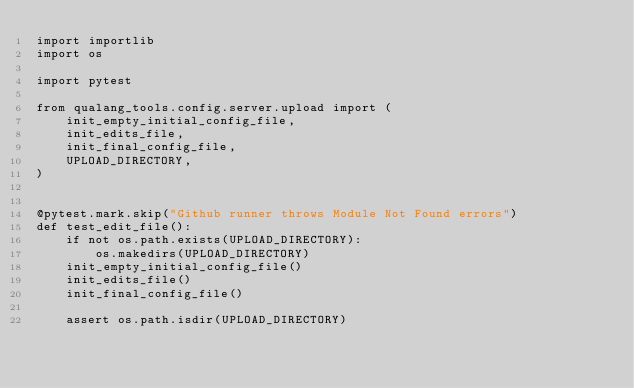Convert code to text. <code><loc_0><loc_0><loc_500><loc_500><_Python_>import importlib
import os

import pytest

from qualang_tools.config.server.upload import (
    init_empty_initial_config_file,
    init_edits_file,
    init_final_config_file,
    UPLOAD_DIRECTORY,
)


@pytest.mark.skip("Github runner throws Module Not Found errors")
def test_edit_file():
    if not os.path.exists(UPLOAD_DIRECTORY):
        os.makedirs(UPLOAD_DIRECTORY)
    init_empty_initial_config_file()
    init_edits_file()
    init_final_config_file()

    assert os.path.isdir(UPLOAD_DIRECTORY)</code> 